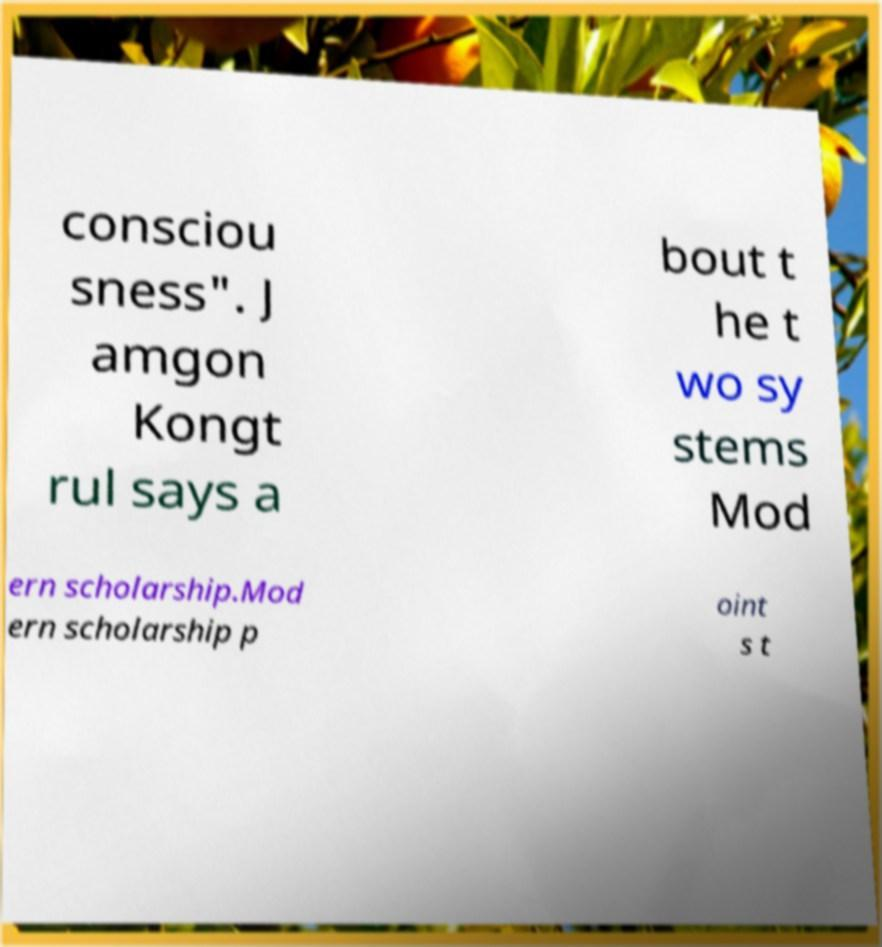For documentation purposes, I need the text within this image transcribed. Could you provide that? consciou sness". J amgon Kongt rul says a bout t he t wo sy stems Mod ern scholarship.Mod ern scholarship p oint s t 